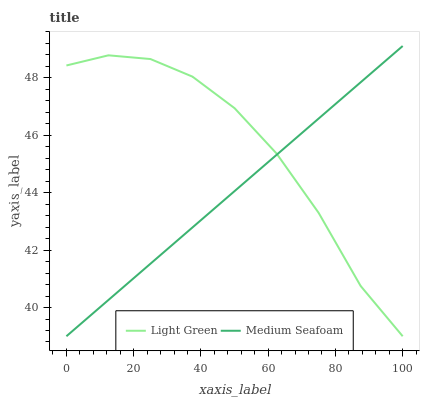Does Medium Seafoam have the minimum area under the curve?
Answer yes or no. Yes. Does Light Green have the maximum area under the curve?
Answer yes or no. Yes. Does Light Green have the minimum area under the curve?
Answer yes or no. No. Is Medium Seafoam the smoothest?
Answer yes or no. Yes. Is Light Green the roughest?
Answer yes or no. Yes. Is Light Green the smoothest?
Answer yes or no. No. Does Medium Seafoam have the lowest value?
Answer yes or no. Yes. Does Medium Seafoam have the highest value?
Answer yes or no. Yes. Does Light Green have the highest value?
Answer yes or no. No. Does Medium Seafoam intersect Light Green?
Answer yes or no. Yes. Is Medium Seafoam less than Light Green?
Answer yes or no. No. Is Medium Seafoam greater than Light Green?
Answer yes or no. No. 